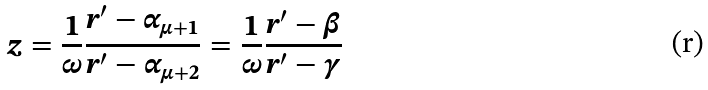Convert formula to latex. <formula><loc_0><loc_0><loc_500><loc_500>z = \frac { 1 } { \omega } \frac { r ^ { \prime } - \alpha _ { \mu + 1 } } { r ^ { \prime } - \alpha _ { \mu + 2 } } = \frac { 1 } { \omega } \frac { r ^ { \prime } - \beta } { r ^ { \prime } - \gamma }</formula> 